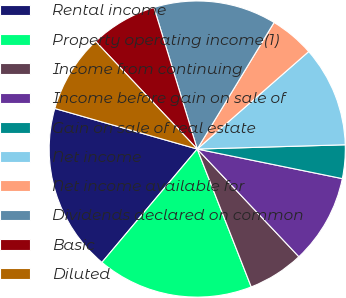<chart> <loc_0><loc_0><loc_500><loc_500><pie_chart><fcel>Rental income<fcel>Property operating income(1)<fcel>Income from continuing<fcel>Income before gain on sale of<fcel>Gain on sale of real estate<fcel>Net income<fcel>Net income available for<fcel>Dividends declared on common<fcel>Basic<fcel>Diluted<nl><fcel>18.29%<fcel>17.07%<fcel>6.1%<fcel>9.76%<fcel>3.66%<fcel>10.98%<fcel>4.88%<fcel>13.41%<fcel>7.32%<fcel>8.54%<nl></chart> 